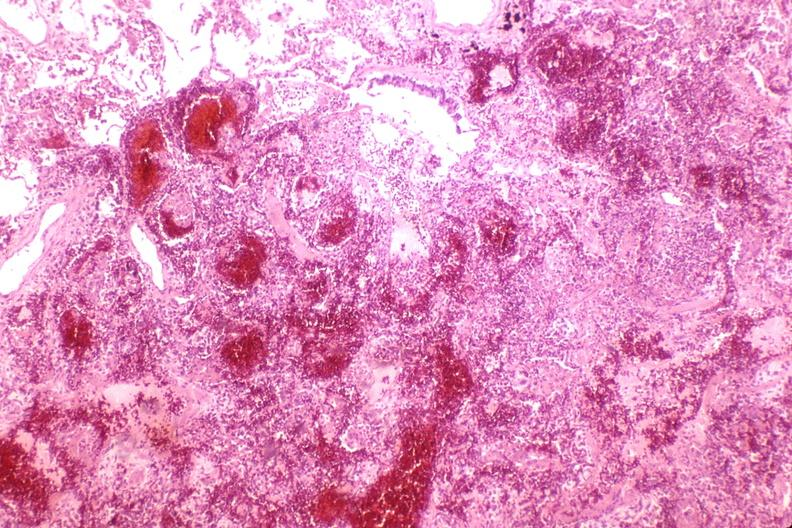s malignant lymphoma large cell type present?
Answer the question using a single word or phrase. No 